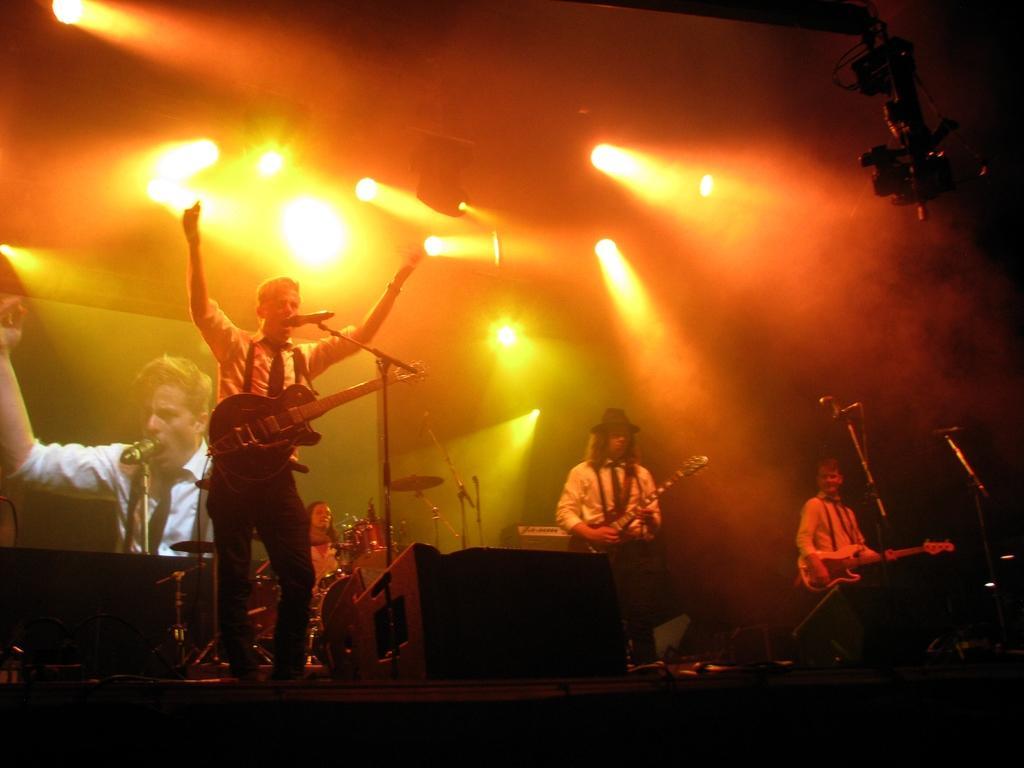Can you describe this image briefly? In the picture there is a man in front with a guitar and there are other musicians in the back side ,on ceiling there are many lights. 